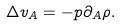Convert formula to latex. <formula><loc_0><loc_0><loc_500><loc_500>\Delta v _ { A } = - p \partial _ { A } \rho .</formula> 